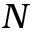Convert formula to latex. <formula><loc_0><loc_0><loc_500><loc_500>N</formula> 